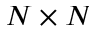Convert formula to latex. <formula><loc_0><loc_0><loc_500><loc_500>N \times N</formula> 